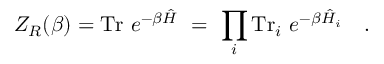<formula> <loc_0><loc_0><loc_500><loc_500>Z _ { R } ( \beta ) = T r e ^ { - \beta \hat { H } } = \prod _ { i } T r _ { i } e ^ { - \beta \hat { H } _ { i } } .</formula> 